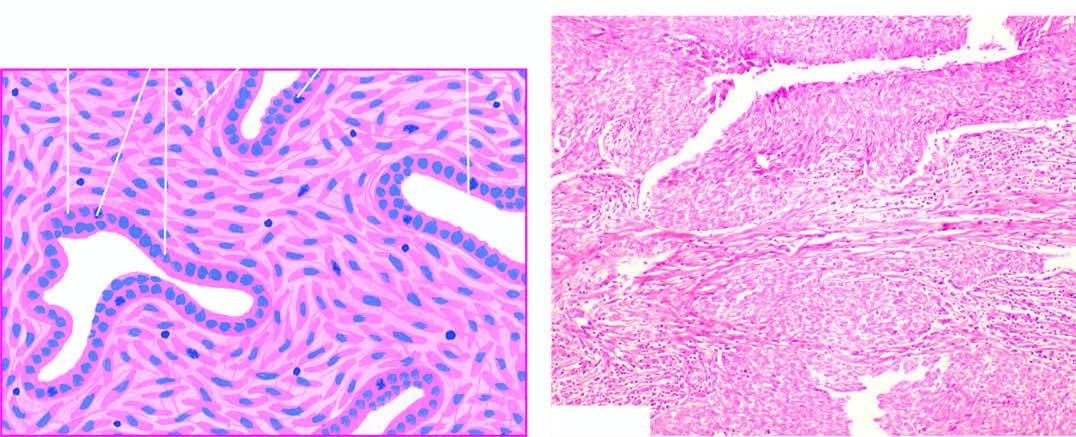what is the tumour composed of?
Answer the question using a single word or phrase. Epithelial-like cells lining cleft-like spaces and gland-like structures 